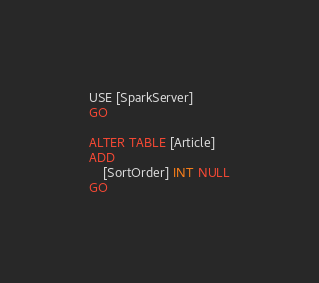Convert code to text. <code><loc_0><loc_0><loc_500><loc_500><_SQL_>USE [SparkServer]
GO

ALTER TABLE [Article]
ADD
	[SortOrder] INT NULL
GO</code> 